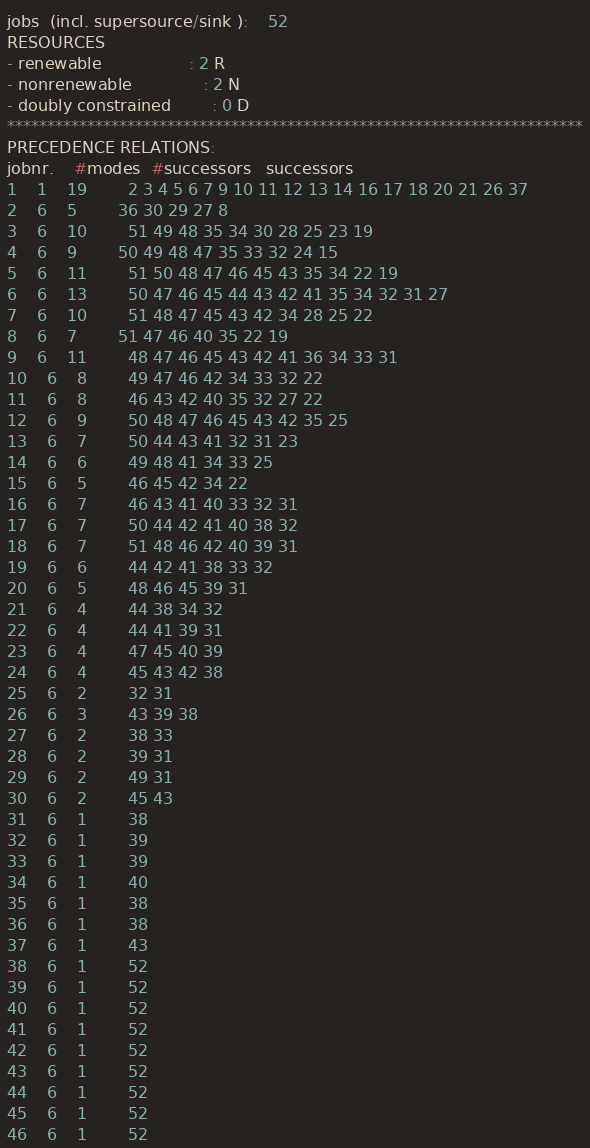Convert code to text. <code><loc_0><loc_0><loc_500><loc_500><_ObjectiveC_>jobs  (incl. supersource/sink ):	52
RESOURCES
- renewable                 : 2 R
- nonrenewable              : 2 N
- doubly constrained        : 0 D
************************************************************************
PRECEDENCE RELATIONS:
jobnr.    #modes  #successors   successors
1	1	19		2 3 4 5 6 7 9 10 11 12 13 14 16 17 18 20 21 26 37 
2	6	5		36 30 29 27 8 
3	6	10		51 49 48 35 34 30 28 25 23 19 
4	6	9		50 49 48 47 35 33 32 24 15 
5	6	11		51 50 48 47 46 45 43 35 34 22 19 
6	6	13		50 47 46 45 44 43 42 41 35 34 32 31 27 
7	6	10		51 48 47 45 43 42 34 28 25 22 
8	6	7		51 47 46 40 35 22 19 
9	6	11		48 47 46 45 43 42 41 36 34 33 31 
10	6	8		49 47 46 42 34 33 32 22 
11	6	8		46 43 42 40 35 32 27 22 
12	6	9		50 48 47 46 45 43 42 35 25 
13	6	7		50 44 43 41 32 31 23 
14	6	6		49 48 41 34 33 25 
15	6	5		46 45 42 34 22 
16	6	7		46 43 41 40 33 32 31 
17	6	7		50 44 42 41 40 38 32 
18	6	7		51 48 46 42 40 39 31 
19	6	6		44 42 41 38 33 32 
20	6	5		48 46 45 39 31 
21	6	4		44 38 34 32 
22	6	4		44 41 39 31 
23	6	4		47 45 40 39 
24	6	4		45 43 42 38 
25	6	2		32 31 
26	6	3		43 39 38 
27	6	2		38 33 
28	6	2		39 31 
29	6	2		49 31 
30	6	2		45 43 
31	6	1		38 
32	6	1		39 
33	6	1		39 
34	6	1		40 
35	6	1		38 
36	6	1		38 
37	6	1		43 
38	6	1		52 
39	6	1		52 
40	6	1		52 
41	6	1		52 
42	6	1		52 
43	6	1		52 
44	6	1		52 
45	6	1		52 
46	6	1		52 </code> 